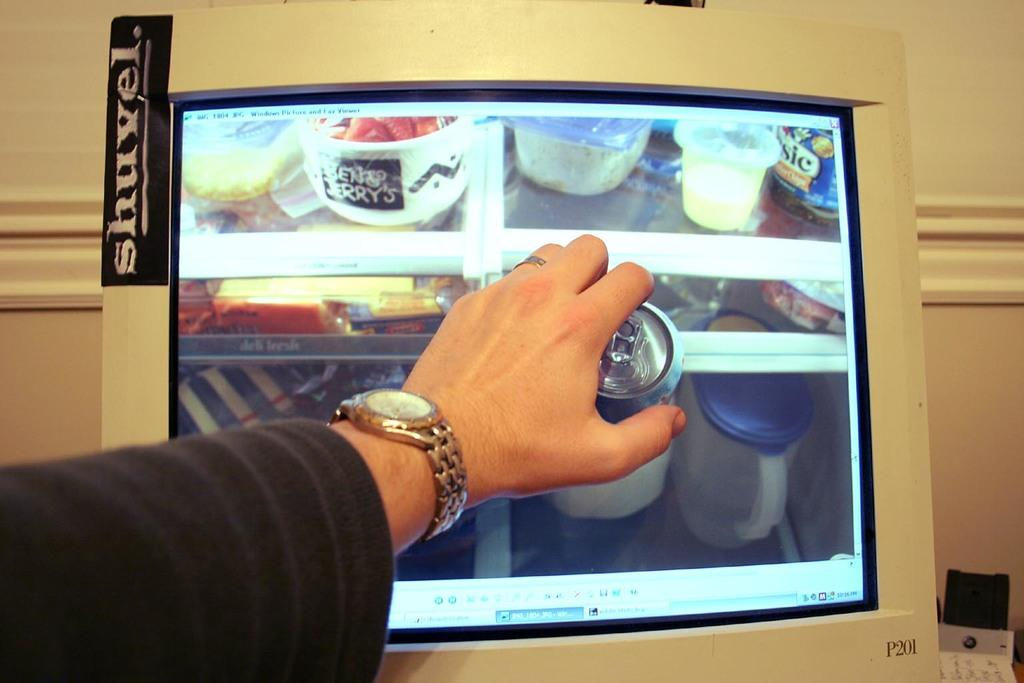<image>
Offer a succinct explanation of the picture presented. A computer monitor that has a sticker that says shuvel on it. 